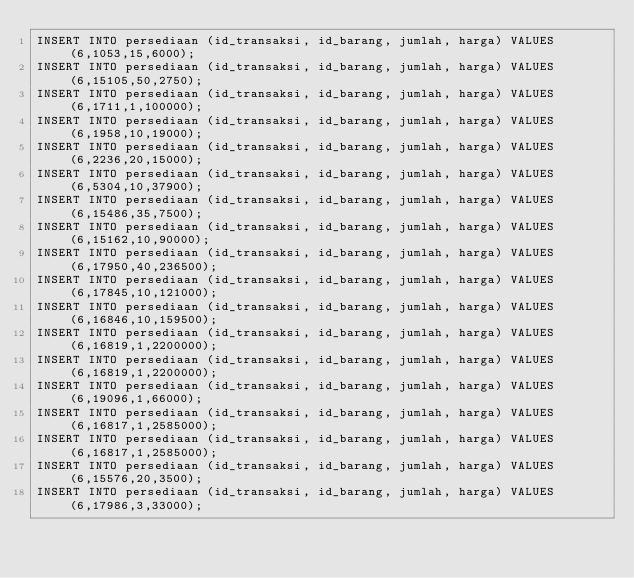Convert code to text. <code><loc_0><loc_0><loc_500><loc_500><_SQL_>INSERT INTO persediaan (id_transaksi, id_barang, jumlah, harga) VALUES (6,1053,15,6000);
INSERT INTO persediaan (id_transaksi, id_barang, jumlah, harga) VALUES (6,15105,50,2750);
INSERT INTO persediaan (id_transaksi, id_barang, jumlah, harga) VALUES (6,1711,1,100000);
INSERT INTO persediaan (id_transaksi, id_barang, jumlah, harga) VALUES (6,1958,10,19000);
INSERT INTO persediaan (id_transaksi, id_barang, jumlah, harga) VALUES (6,2236,20,15000);
INSERT INTO persediaan (id_transaksi, id_barang, jumlah, harga) VALUES (6,5304,10,37900);
INSERT INTO persediaan (id_transaksi, id_barang, jumlah, harga) VALUES (6,15486,35,7500);
INSERT INTO persediaan (id_transaksi, id_barang, jumlah, harga) VALUES (6,15162,10,90000);
INSERT INTO persediaan (id_transaksi, id_barang, jumlah, harga) VALUES (6,17950,40,236500);
INSERT INTO persediaan (id_transaksi, id_barang, jumlah, harga) VALUES (6,17845,10,121000);
INSERT INTO persediaan (id_transaksi, id_barang, jumlah, harga) VALUES (6,16846,10,159500);
INSERT INTO persediaan (id_transaksi, id_barang, jumlah, harga) VALUES (6,16819,1,2200000);
INSERT INTO persediaan (id_transaksi, id_barang, jumlah, harga) VALUES (6,16819,1,2200000);
INSERT INTO persediaan (id_transaksi, id_barang, jumlah, harga) VALUES (6,19096,1,66000);
INSERT INTO persediaan (id_transaksi, id_barang, jumlah, harga) VALUES (6,16817,1,2585000);
INSERT INTO persediaan (id_transaksi, id_barang, jumlah, harga) VALUES (6,16817,1,2585000);
INSERT INTO persediaan (id_transaksi, id_barang, jumlah, harga) VALUES (6,15576,20,3500);
INSERT INTO persediaan (id_transaksi, id_barang, jumlah, harga) VALUES (6,17986,3,33000);</code> 